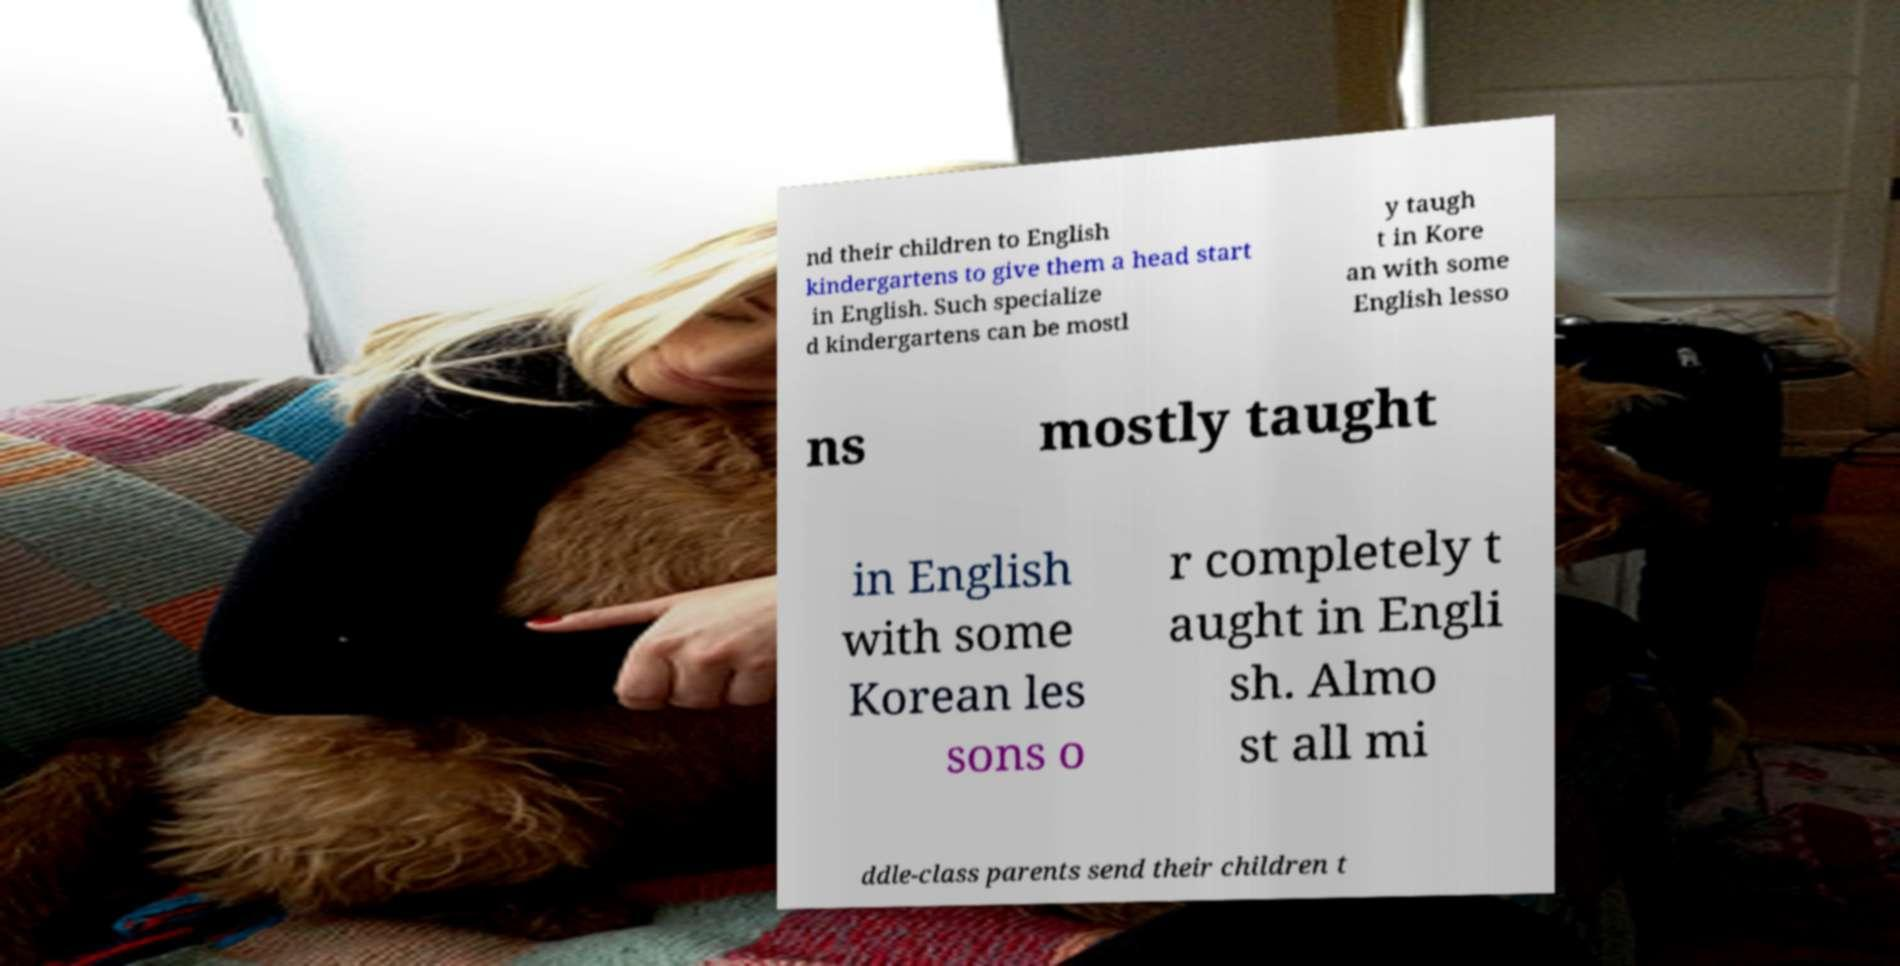Can you accurately transcribe the text from the provided image for me? nd their children to English kindergartens to give them a head start in English. Such specialize d kindergartens can be mostl y taugh t in Kore an with some English lesso ns mostly taught in English with some Korean les sons o r completely t aught in Engli sh. Almo st all mi ddle-class parents send their children t 